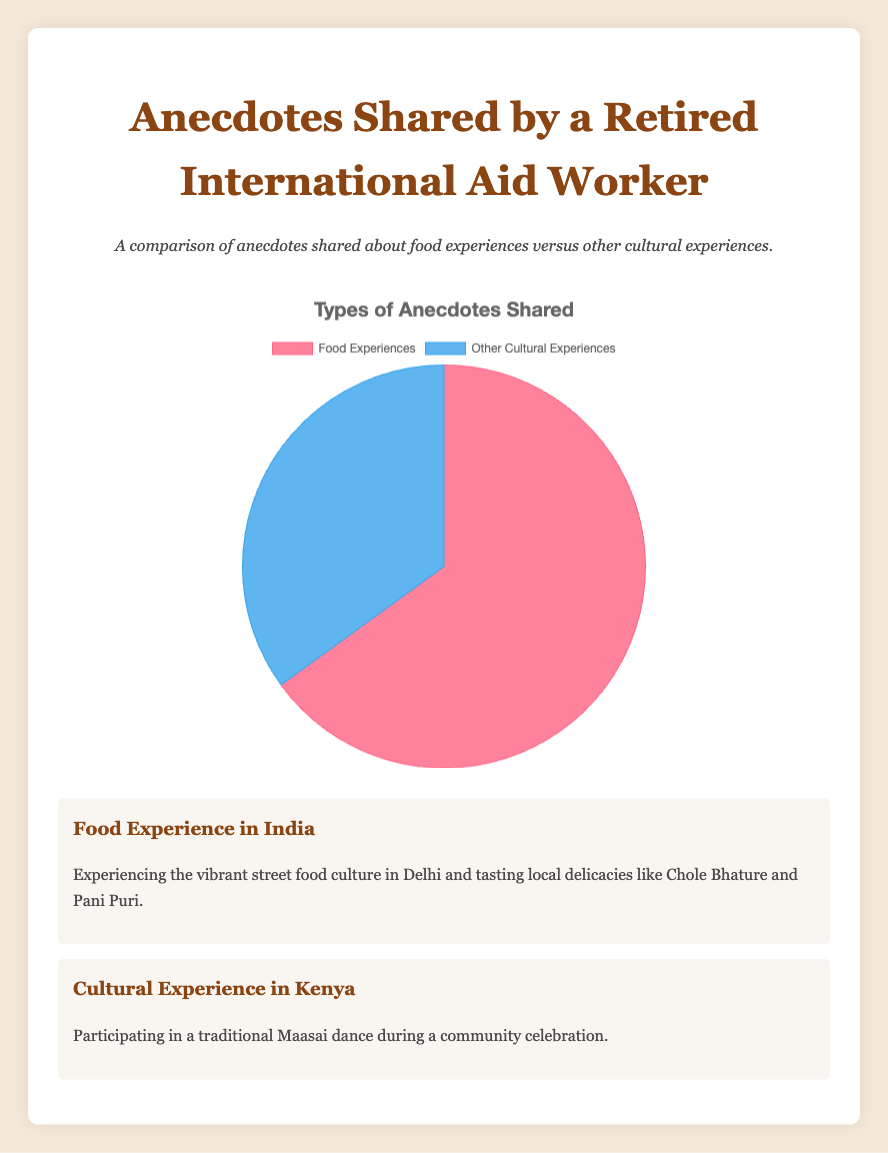What are the two categories compared in the pie chart? The pie chart compares "Food Experiences" and "Other Cultural Experiences." This information is visible from the labels directly below each segment of the pie chart.
Answer: Food Experiences, Other Cultural Experiences Which category shares more anecdotes? By looking at the size of the pie segments, the "Food Experiences" segment is larger than the "Other Cultural Experiences" segment. Therefore, "Food Experiences" shares more anecdotes.
Answer: Food Experiences What is the ratio of anecdotes shared about food experiences to other cultural experiences? The ratio can be calculated by dividing the number of anecdotes for "Food Experiences" by the number of anecdotes for "Other Cultural Experiences." The values are 65 for food experiences and 35 for other cultural experiences. Hence, the ratio is 65/35, which simplifies to 13/7.
Answer: 13:7 What percentage of the anecdotes are about other cultural experiences? The total number of anecdotes is 65 (food experiences) + 35 (other cultural experiences) = 100. The percentage of other cultural experiences is (35/100) * 100 = 35%.
Answer: 35% How many more anecdotes are shared about food experiences than other cultural experiences? Subtract the number of anecdotes for other cultural experiences from the number of anecdotes for food experiences. That is, 65 (food experiences) - 35 (other cultural experiences) = 30.
Answer: 30 In which country is an example of a food experience shared? The examples provided under food experiences include India, Italy, and Thailand. This can be noted from the detailed anecdotes listed for food experiences.
Answer: India, Italy, Thailand Which color represents "Food Experiences" in the pie chart? By observing the color key of the pie chart, the segment labeled "Food Experiences" is represented in red.
Answer: Red What is the sum of the anecdotal values? Adding up the anecdotal values for both categories gives 65 (food experiences) + 35 (other cultural experiences) = 100.
Answer: 100 Is the number of anecdotes about other cultural experiences greater, lesser, or equal to the number of anecdotes about food experiences? The figure shows that the number of anecdotes about other cultural experiences is lesser than the number of anecdotes about food experiences.
Answer: Lesser What cultural experience is shared about Kenya? One of the examples listed for other cultural experiences includes participating in a traditional Maasai dance in Kenya.
Answer: Participating in a traditional Maasai dance 